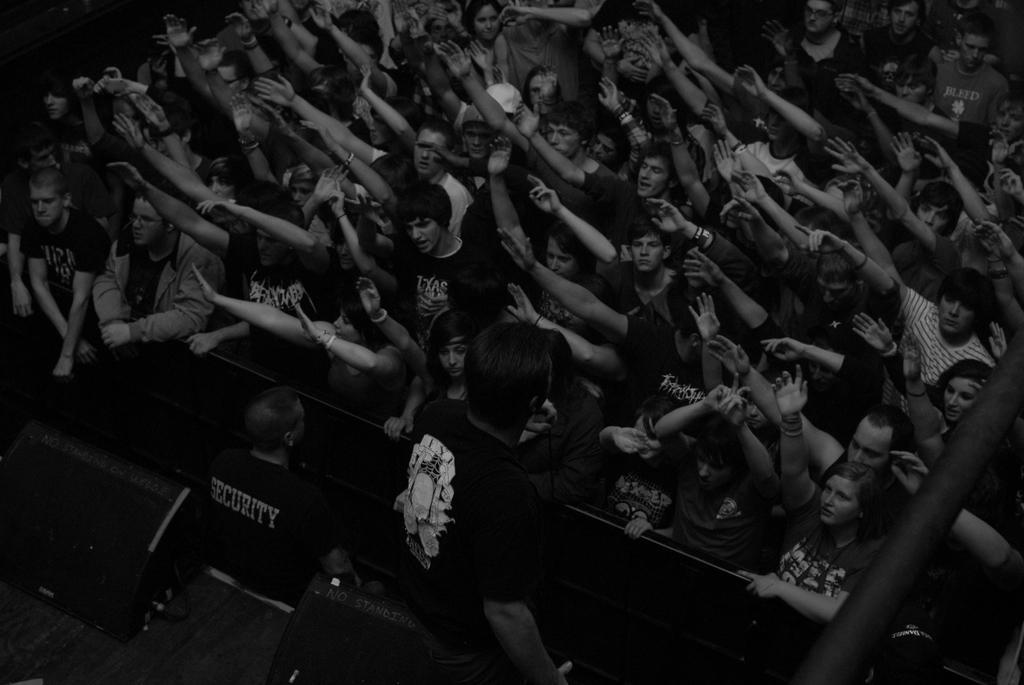Could you give a brief overview of what you see in this image? This is a black and white image. In this image we can see crowd. At the bottom of the image we can see persons and speakers. 